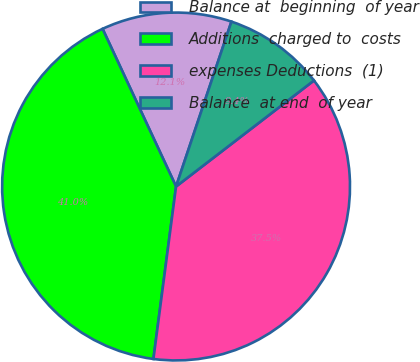<chart> <loc_0><loc_0><loc_500><loc_500><pie_chart><fcel>Balance at  beginning  of year<fcel>Additions  charged to  costs<fcel>expenses Deductions  (1)<fcel>Balance  at end  of year<nl><fcel>12.1%<fcel>40.98%<fcel>37.51%<fcel>9.41%<nl></chart> 